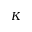<formula> <loc_0><loc_0><loc_500><loc_500>K</formula> 